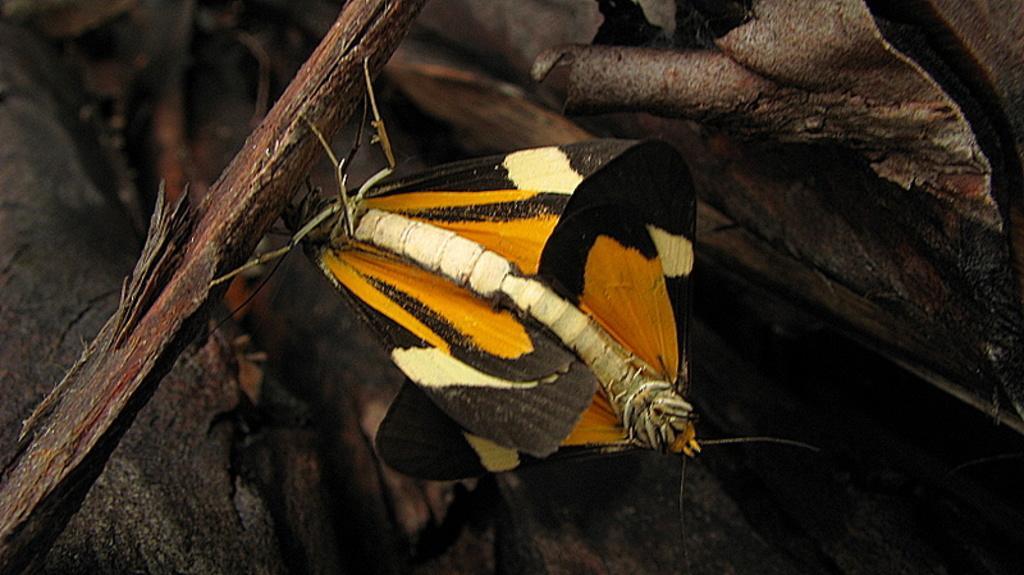Please provide a concise description of this image. In the foreground of the picture there are insects, trunk of a tree and other objects. The background is not clear. 